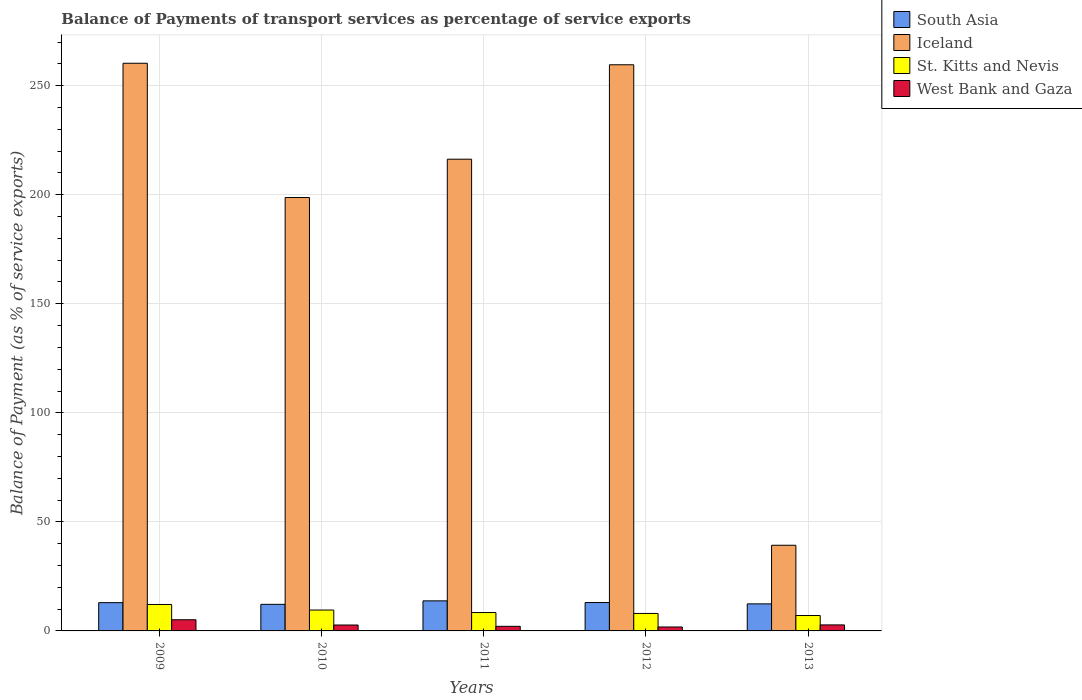How many different coloured bars are there?
Your answer should be very brief. 4. How many groups of bars are there?
Make the answer very short. 5. How many bars are there on the 4th tick from the right?
Give a very brief answer. 4. What is the label of the 3rd group of bars from the left?
Offer a terse response. 2011. What is the balance of payments of transport services in West Bank and Gaza in 2009?
Offer a very short reply. 5.12. Across all years, what is the maximum balance of payments of transport services in Iceland?
Keep it short and to the point. 260.27. Across all years, what is the minimum balance of payments of transport services in St. Kitts and Nevis?
Provide a short and direct response. 7.06. In which year was the balance of payments of transport services in Iceland maximum?
Give a very brief answer. 2009. In which year was the balance of payments of transport services in West Bank and Gaza minimum?
Keep it short and to the point. 2012. What is the total balance of payments of transport services in South Asia in the graph?
Offer a terse response. 64.36. What is the difference between the balance of payments of transport services in South Asia in 2009 and that in 2013?
Keep it short and to the point. 0.56. What is the difference between the balance of payments of transport services in South Asia in 2010 and the balance of payments of transport services in St. Kitts and Nevis in 2013?
Offer a very short reply. 5.13. What is the average balance of payments of transport services in West Bank and Gaza per year?
Give a very brief answer. 2.9. In the year 2013, what is the difference between the balance of payments of transport services in St. Kitts and Nevis and balance of payments of transport services in South Asia?
Provide a short and direct response. -5.34. What is the ratio of the balance of payments of transport services in Iceland in 2010 to that in 2013?
Offer a terse response. 5.06. Is the balance of payments of transport services in Iceland in 2012 less than that in 2013?
Provide a short and direct response. No. What is the difference between the highest and the second highest balance of payments of transport services in Iceland?
Provide a succinct answer. 0.7. What is the difference between the highest and the lowest balance of payments of transport services in Iceland?
Ensure brevity in your answer.  221. In how many years, is the balance of payments of transport services in South Asia greater than the average balance of payments of transport services in South Asia taken over all years?
Provide a succinct answer. 3. Is the sum of the balance of payments of transport services in South Asia in 2009 and 2011 greater than the maximum balance of payments of transport services in West Bank and Gaza across all years?
Provide a succinct answer. Yes. Is it the case that in every year, the sum of the balance of payments of transport services in South Asia and balance of payments of transport services in West Bank and Gaza is greater than the sum of balance of payments of transport services in St. Kitts and Nevis and balance of payments of transport services in Iceland?
Make the answer very short. No. What does the 4th bar from the left in 2009 represents?
Give a very brief answer. West Bank and Gaza. What does the 2nd bar from the right in 2010 represents?
Keep it short and to the point. St. Kitts and Nevis. Are the values on the major ticks of Y-axis written in scientific E-notation?
Offer a terse response. No. How many legend labels are there?
Provide a short and direct response. 4. What is the title of the graph?
Your response must be concise. Balance of Payments of transport services as percentage of service exports. Does "Korea (Republic)" appear as one of the legend labels in the graph?
Your response must be concise. No. What is the label or title of the Y-axis?
Ensure brevity in your answer.  Balance of Payment (as % of service exports). What is the Balance of Payment (as % of service exports) in South Asia in 2009?
Offer a terse response. 12.96. What is the Balance of Payment (as % of service exports) of Iceland in 2009?
Your response must be concise. 260.27. What is the Balance of Payment (as % of service exports) of St. Kitts and Nevis in 2009?
Provide a succinct answer. 12.13. What is the Balance of Payment (as % of service exports) in West Bank and Gaza in 2009?
Offer a terse response. 5.12. What is the Balance of Payment (as % of service exports) in South Asia in 2010?
Offer a terse response. 12.19. What is the Balance of Payment (as % of service exports) of Iceland in 2010?
Make the answer very short. 198.71. What is the Balance of Payment (as % of service exports) in St. Kitts and Nevis in 2010?
Offer a very short reply. 9.57. What is the Balance of Payment (as % of service exports) in West Bank and Gaza in 2010?
Offer a terse response. 2.71. What is the Balance of Payment (as % of service exports) of South Asia in 2011?
Make the answer very short. 13.79. What is the Balance of Payment (as % of service exports) in Iceland in 2011?
Make the answer very short. 216.28. What is the Balance of Payment (as % of service exports) of St. Kitts and Nevis in 2011?
Your response must be concise. 8.43. What is the Balance of Payment (as % of service exports) of West Bank and Gaza in 2011?
Provide a short and direct response. 2.1. What is the Balance of Payment (as % of service exports) of South Asia in 2012?
Offer a terse response. 13.02. What is the Balance of Payment (as % of service exports) of Iceland in 2012?
Give a very brief answer. 259.57. What is the Balance of Payment (as % of service exports) of St. Kitts and Nevis in 2012?
Your answer should be compact. 8.02. What is the Balance of Payment (as % of service exports) in West Bank and Gaza in 2012?
Your response must be concise. 1.81. What is the Balance of Payment (as % of service exports) in South Asia in 2013?
Give a very brief answer. 12.41. What is the Balance of Payment (as % of service exports) of Iceland in 2013?
Provide a succinct answer. 39.27. What is the Balance of Payment (as % of service exports) in St. Kitts and Nevis in 2013?
Your answer should be compact. 7.06. What is the Balance of Payment (as % of service exports) of West Bank and Gaza in 2013?
Your answer should be compact. 2.76. Across all years, what is the maximum Balance of Payment (as % of service exports) of South Asia?
Your answer should be compact. 13.79. Across all years, what is the maximum Balance of Payment (as % of service exports) in Iceland?
Your answer should be very brief. 260.27. Across all years, what is the maximum Balance of Payment (as % of service exports) of St. Kitts and Nevis?
Give a very brief answer. 12.13. Across all years, what is the maximum Balance of Payment (as % of service exports) in West Bank and Gaza?
Ensure brevity in your answer.  5.12. Across all years, what is the minimum Balance of Payment (as % of service exports) of South Asia?
Your response must be concise. 12.19. Across all years, what is the minimum Balance of Payment (as % of service exports) in Iceland?
Provide a short and direct response. 39.27. Across all years, what is the minimum Balance of Payment (as % of service exports) in St. Kitts and Nevis?
Your response must be concise. 7.06. Across all years, what is the minimum Balance of Payment (as % of service exports) in West Bank and Gaza?
Keep it short and to the point. 1.81. What is the total Balance of Payment (as % of service exports) in South Asia in the graph?
Ensure brevity in your answer.  64.36. What is the total Balance of Payment (as % of service exports) of Iceland in the graph?
Make the answer very short. 974.1. What is the total Balance of Payment (as % of service exports) of St. Kitts and Nevis in the graph?
Your response must be concise. 45.21. What is the total Balance of Payment (as % of service exports) of West Bank and Gaza in the graph?
Give a very brief answer. 14.5. What is the difference between the Balance of Payment (as % of service exports) of South Asia in 2009 and that in 2010?
Keep it short and to the point. 0.78. What is the difference between the Balance of Payment (as % of service exports) in Iceland in 2009 and that in 2010?
Ensure brevity in your answer.  61.56. What is the difference between the Balance of Payment (as % of service exports) of St. Kitts and Nevis in 2009 and that in 2010?
Offer a terse response. 2.56. What is the difference between the Balance of Payment (as % of service exports) in West Bank and Gaza in 2009 and that in 2010?
Your answer should be compact. 2.4. What is the difference between the Balance of Payment (as % of service exports) in South Asia in 2009 and that in 2011?
Your answer should be very brief. -0.82. What is the difference between the Balance of Payment (as % of service exports) of Iceland in 2009 and that in 2011?
Your answer should be compact. 43.99. What is the difference between the Balance of Payment (as % of service exports) in St. Kitts and Nevis in 2009 and that in 2011?
Make the answer very short. 3.7. What is the difference between the Balance of Payment (as % of service exports) of West Bank and Gaza in 2009 and that in 2011?
Provide a succinct answer. 3.01. What is the difference between the Balance of Payment (as % of service exports) of South Asia in 2009 and that in 2012?
Make the answer very short. -0.05. What is the difference between the Balance of Payment (as % of service exports) of Iceland in 2009 and that in 2012?
Offer a very short reply. 0.7. What is the difference between the Balance of Payment (as % of service exports) in St. Kitts and Nevis in 2009 and that in 2012?
Offer a terse response. 4.11. What is the difference between the Balance of Payment (as % of service exports) in West Bank and Gaza in 2009 and that in 2012?
Offer a very short reply. 3.31. What is the difference between the Balance of Payment (as % of service exports) in South Asia in 2009 and that in 2013?
Ensure brevity in your answer.  0.56. What is the difference between the Balance of Payment (as % of service exports) of Iceland in 2009 and that in 2013?
Give a very brief answer. 221. What is the difference between the Balance of Payment (as % of service exports) in St. Kitts and Nevis in 2009 and that in 2013?
Provide a short and direct response. 5.07. What is the difference between the Balance of Payment (as % of service exports) of West Bank and Gaza in 2009 and that in 2013?
Keep it short and to the point. 2.36. What is the difference between the Balance of Payment (as % of service exports) of South Asia in 2010 and that in 2011?
Keep it short and to the point. -1.6. What is the difference between the Balance of Payment (as % of service exports) of Iceland in 2010 and that in 2011?
Your answer should be compact. -17.57. What is the difference between the Balance of Payment (as % of service exports) of St. Kitts and Nevis in 2010 and that in 2011?
Provide a short and direct response. 1.14. What is the difference between the Balance of Payment (as % of service exports) of West Bank and Gaza in 2010 and that in 2011?
Ensure brevity in your answer.  0.61. What is the difference between the Balance of Payment (as % of service exports) in South Asia in 2010 and that in 2012?
Your answer should be very brief. -0.83. What is the difference between the Balance of Payment (as % of service exports) of Iceland in 2010 and that in 2012?
Provide a short and direct response. -60.86. What is the difference between the Balance of Payment (as % of service exports) in St. Kitts and Nevis in 2010 and that in 2012?
Your answer should be very brief. 1.56. What is the difference between the Balance of Payment (as % of service exports) in West Bank and Gaza in 2010 and that in 2012?
Offer a very short reply. 0.91. What is the difference between the Balance of Payment (as % of service exports) of South Asia in 2010 and that in 2013?
Your answer should be very brief. -0.22. What is the difference between the Balance of Payment (as % of service exports) of Iceland in 2010 and that in 2013?
Offer a terse response. 159.43. What is the difference between the Balance of Payment (as % of service exports) of St. Kitts and Nevis in 2010 and that in 2013?
Your answer should be very brief. 2.51. What is the difference between the Balance of Payment (as % of service exports) in West Bank and Gaza in 2010 and that in 2013?
Your answer should be very brief. -0.04. What is the difference between the Balance of Payment (as % of service exports) of South Asia in 2011 and that in 2012?
Your answer should be compact. 0.77. What is the difference between the Balance of Payment (as % of service exports) in Iceland in 2011 and that in 2012?
Give a very brief answer. -43.29. What is the difference between the Balance of Payment (as % of service exports) of St. Kitts and Nevis in 2011 and that in 2012?
Your response must be concise. 0.42. What is the difference between the Balance of Payment (as % of service exports) in West Bank and Gaza in 2011 and that in 2012?
Keep it short and to the point. 0.3. What is the difference between the Balance of Payment (as % of service exports) of South Asia in 2011 and that in 2013?
Provide a short and direct response. 1.38. What is the difference between the Balance of Payment (as % of service exports) in Iceland in 2011 and that in 2013?
Make the answer very short. 177.01. What is the difference between the Balance of Payment (as % of service exports) in St. Kitts and Nevis in 2011 and that in 2013?
Offer a terse response. 1.37. What is the difference between the Balance of Payment (as % of service exports) in West Bank and Gaza in 2011 and that in 2013?
Keep it short and to the point. -0.65. What is the difference between the Balance of Payment (as % of service exports) in South Asia in 2012 and that in 2013?
Ensure brevity in your answer.  0.61. What is the difference between the Balance of Payment (as % of service exports) in Iceland in 2012 and that in 2013?
Keep it short and to the point. 220.3. What is the difference between the Balance of Payment (as % of service exports) of St. Kitts and Nevis in 2012 and that in 2013?
Your answer should be compact. 0.95. What is the difference between the Balance of Payment (as % of service exports) of West Bank and Gaza in 2012 and that in 2013?
Give a very brief answer. -0.95. What is the difference between the Balance of Payment (as % of service exports) in South Asia in 2009 and the Balance of Payment (as % of service exports) in Iceland in 2010?
Your answer should be very brief. -185.74. What is the difference between the Balance of Payment (as % of service exports) in South Asia in 2009 and the Balance of Payment (as % of service exports) in St. Kitts and Nevis in 2010?
Offer a terse response. 3.39. What is the difference between the Balance of Payment (as % of service exports) of South Asia in 2009 and the Balance of Payment (as % of service exports) of West Bank and Gaza in 2010?
Offer a terse response. 10.25. What is the difference between the Balance of Payment (as % of service exports) in Iceland in 2009 and the Balance of Payment (as % of service exports) in St. Kitts and Nevis in 2010?
Give a very brief answer. 250.7. What is the difference between the Balance of Payment (as % of service exports) of Iceland in 2009 and the Balance of Payment (as % of service exports) of West Bank and Gaza in 2010?
Offer a terse response. 257.55. What is the difference between the Balance of Payment (as % of service exports) in St. Kitts and Nevis in 2009 and the Balance of Payment (as % of service exports) in West Bank and Gaza in 2010?
Keep it short and to the point. 9.41. What is the difference between the Balance of Payment (as % of service exports) in South Asia in 2009 and the Balance of Payment (as % of service exports) in Iceland in 2011?
Provide a short and direct response. -203.32. What is the difference between the Balance of Payment (as % of service exports) in South Asia in 2009 and the Balance of Payment (as % of service exports) in St. Kitts and Nevis in 2011?
Offer a terse response. 4.53. What is the difference between the Balance of Payment (as % of service exports) of South Asia in 2009 and the Balance of Payment (as % of service exports) of West Bank and Gaza in 2011?
Provide a succinct answer. 10.86. What is the difference between the Balance of Payment (as % of service exports) of Iceland in 2009 and the Balance of Payment (as % of service exports) of St. Kitts and Nevis in 2011?
Offer a very short reply. 251.84. What is the difference between the Balance of Payment (as % of service exports) in Iceland in 2009 and the Balance of Payment (as % of service exports) in West Bank and Gaza in 2011?
Provide a succinct answer. 258.16. What is the difference between the Balance of Payment (as % of service exports) in St. Kitts and Nevis in 2009 and the Balance of Payment (as % of service exports) in West Bank and Gaza in 2011?
Keep it short and to the point. 10.02. What is the difference between the Balance of Payment (as % of service exports) in South Asia in 2009 and the Balance of Payment (as % of service exports) in Iceland in 2012?
Your answer should be very brief. -246.61. What is the difference between the Balance of Payment (as % of service exports) of South Asia in 2009 and the Balance of Payment (as % of service exports) of St. Kitts and Nevis in 2012?
Provide a succinct answer. 4.95. What is the difference between the Balance of Payment (as % of service exports) in South Asia in 2009 and the Balance of Payment (as % of service exports) in West Bank and Gaza in 2012?
Provide a short and direct response. 11.16. What is the difference between the Balance of Payment (as % of service exports) of Iceland in 2009 and the Balance of Payment (as % of service exports) of St. Kitts and Nevis in 2012?
Give a very brief answer. 252.25. What is the difference between the Balance of Payment (as % of service exports) in Iceland in 2009 and the Balance of Payment (as % of service exports) in West Bank and Gaza in 2012?
Provide a succinct answer. 258.46. What is the difference between the Balance of Payment (as % of service exports) of St. Kitts and Nevis in 2009 and the Balance of Payment (as % of service exports) of West Bank and Gaza in 2012?
Keep it short and to the point. 10.32. What is the difference between the Balance of Payment (as % of service exports) in South Asia in 2009 and the Balance of Payment (as % of service exports) in Iceland in 2013?
Provide a short and direct response. -26.31. What is the difference between the Balance of Payment (as % of service exports) in South Asia in 2009 and the Balance of Payment (as % of service exports) in St. Kitts and Nevis in 2013?
Ensure brevity in your answer.  5.9. What is the difference between the Balance of Payment (as % of service exports) in South Asia in 2009 and the Balance of Payment (as % of service exports) in West Bank and Gaza in 2013?
Keep it short and to the point. 10.21. What is the difference between the Balance of Payment (as % of service exports) in Iceland in 2009 and the Balance of Payment (as % of service exports) in St. Kitts and Nevis in 2013?
Offer a terse response. 253.21. What is the difference between the Balance of Payment (as % of service exports) of Iceland in 2009 and the Balance of Payment (as % of service exports) of West Bank and Gaza in 2013?
Offer a terse response. 257.51. What is the difference between the Balance of Payment (as % of service exports) in St. Kitts and Nevis in 2009 and the Balance of Payment (as % of service exports) in West Bank and Gaza in 2013?
Give a very brief answer. 9.37. What is the difference between the Balance of Payment (as % of service exports) of South Asia in 2010 and the Balance of Payment (as % of service exports) of Iceland in 2011?
Your answer should be very brief. -204.09. What is the difference between the Balance of Payment (as % of service exports) in South Asia in 2010 and the Balance of Payment (as % of service exports) in St. Kitts and Nevis in 2011?
Ensure brevity in your answer.  3.75. What is the difference between the Balance of Payment (as % of service exports) in South Asia in 2010 and the Balance of Payment (as % of service exports) in West Bank and Gaza in 2011?
Your response must be concise. 10.08. What is the difference between the Balance of Payment (as % of service exports) in Iceland in 2010 and the Balance of Payment (as % of service exports) in St. Kitts and Nevis in 2011?
Your response must be concise. 190.28. What is the difference between the Balance of Payment (as % of service exports) of Iceland in 2010 and the Balance of Payment (as % of service exports) of West Bank and Gaza in 2011?
Offer a terse response. 196.6. What is the difference between the Balance of Payment (as % of service exports) in St. Kitts and Nevis in 2010 and the Balance of Payment (as % of service exports) in West Bank and Gaza in 2011?
Offer a very short reply. 7.47. What is the difference between the Balance of Payment (as % of service exports) in South Asia in 2010 and the Balance of Payment (as % of service exports) in Iceland in 2012?
Make the answer very short. -247.38. What is the difference between the Balance of Payment (as % of service exports) in South Asia in 2010 and the Balance of Payment (as % of service exports) in St. Kitts and Nevis in 2012?
Provide a short and direct response. 4.17. What is the difference between the Balance of Payment (as % of service exports) of South Asia in 2010 and the Balance of Payment (as % of service exports) of West Bank and Gaza in 2012?
Keep it short and to the point. 10.38. What is the difference between the Balance of Payment (as % of service exports) in Iceland in 2010 and the Balance of Payment (as % of service exports) in St. Kitts and Nevis in 2012?
Give a very brief answer. 190.69. What is the difference between the Balance of Payment (as % of service exports) in Iceland in 2010 and the Balance of Payment (as % of service exports) in West Bank and Gaza in 2012?
Your answer should be very brief. 196.9. What is the difference between the Balance of Payment (as % of service exports) in St. Kitts and Nevis in 2010 and the Balance of Payment (as % of service exports) in West Bank and Gaza in 2012?
Provide a succinct answer. 7.77. What is the difference between the Balance of Payment (as % of service exports) of South Asia in 2010 and the Balance of Payment (as % of service exports) of Iceland in 2013?
Provide a succinct answer. -27.09. What is the difference between the Balance of Payment (as % of service exports) in South Asia in 2010 and the Balance of Payment (as % of service exports) in St. Kitts and Nevis in 2013?
Keep it short and to the point. 5.13. What is the difference between the Balance of Payment (as % of service exports) in South Asia in 2010 and the Balance of Payment (as % of service exports) in West Bank and Gaza in 2013?
Offer a very short reply. 9.43. What is the difference between the Balance of Payment (as % of service exports) in Iceland in 2010 and the Balance of Payment (as % of service exports) in St. Kitts and Nevis in 2013?
Provide a succinct answer. 191.65. What is the difference between the Balance of Payment (as % of service exports) of Iceland in 2010 and the Balance of Payment (as % of service exports) of West Bank and Gaza in 2013?
Give a very brief answer. 195.95. What is the difference between the Balance of Payment (as % of service exports) in St. Kitts and Nevis in 2010 and the Balance of Payment (as % of service exports) in West Bank and Gaza in 2013?
Give a very brief answer. 6.81. What is the difference between the Balance of Payment (as % of service exports) in South Asia in 2011 and the Balance of Payment (as % of service exports) in Iceland in 2012?
Provide a succinct answer. -245.78. What is the difference between the Balance of Payment (as % of service exports) in South Asia in 2011 and the Balance of Payment (as % of service exports) in St. Kitts and Nevis in 2012?
Your answer should be very brief. 5.77. What is the difference between the Balance of Payment (as % of service exports) of South Asia in 2011 and the Balance of Payment (as % of service exports) of West Bank and Gaza in 2012?
Your answer should be very brief. 11.98. What is the difference between the Balance of Payment (as % of service exports) in Iceland in 2011 and the Balance of Payment (as % of service exports) in St. Kitts and Nevis in 2012?
Your answer should be compact. 208.27. What is the difference between the Balance of Payment (as % of service exports) in Iceland in 2011 and the Balance of Payment (as % of service exports) in West Bank and Gaza in 2012?
Offer a very short reply. 214.48. What is the difference between the Balance of Payment (as % of service exports) of St. Kitts and Nevis in 2011 and the Balance of Payment (as % of service exports) of West Bank and Gaza in 2012?
Give a very brief answer. 6.63. What is the difference between the Balance of Payment (as % of service exports) in South Asia in 2011 and the Balance of Payment (as % of service exports) in Iceland in 2013?
Ensure brevity in your answer.  -25.49. What is the difference between the Balance of Payment (as % of service exports) in South Asia in 2011 and the Balance of Payment (as % of service exports) in St. Kitts and Nevis in 2013?
Offer a very short reply. 6.73. What is the difference between the Balance of Payment (as % of service exports) of South Asia in 2011 and the Balance of Payment (as % of service exports) of West Bank and Gaza in 2013?
Ensure brevity in your answer.  11.03. What is the difference between the Balance of Payment (as % of service exports) of Iceland in 2011 and the Balance of Payment (as % of service exports) of St. Kitts and Nevis in 2013?
Make the answer very short. 209.22. What is the difference between the Balance of Payment (as % of service exports) of Iceland in 2011 and the Balance of Payment (as % of service exports) of West Bank and Gaza in 2013?
Provide a short and direct response. 213.52. What is the difference between the Balance of Payment (as % of service exports) of St. Kitts and Nevis in 2011 and the Balance of Payment (as % of service exports) of West Bank and Gaza in 2013?
Offer a terse response. 5.67. What is the difference between the Balance of Payment (as % of service exports) of South Asia in 2012 and the Balance of Payment (as % of service exports) of Iceland in 2013?
Give a very brief answer. -26.25. What is the difference between the Balance of Payment (as % of service exports) of South Asia in 2012 and the Balance of Payment (as % of service exports) of St. Kitts and Nevis in 2013?
Provide a succinct answer. 5.96. What is the difference between the Balance of Payment (as % of service exports) in South Asia in 2012 and the Balance of Payment (as % of service exports) in West Bank and Gaza in 2013?
Keep it short and to the point. 10.26. What is the difference between the Balance of Payment (as % of service exports) of Iceland in 2012 and the Balance of Payment (as % of service exports) of St. Kitts and Nevis in 2013?
Provide a short and direct response. 252.51. What is the difference between the Balance of Payment (as % of service exports) in Iceland in 2012 and the Balance of Payment (as % of service exports) in West Bank and Gaza in 2013?
Offer a terse response. 256.81. What is the difference between the Balance of Payment (as % of service exports) of St. Kitts and Nevis in 2012 and the Balance of Payment (as % of service exports) of West Bank and Gaza in 2013?
Ensure brevity in your answer.  5.26. What is the average Balance of Payment (as % of service exports) in South Asia per year?
Your answer should be very brief. 12.87. What is the average Balance of Payment (as % of service exports) in Iceland per year?
Keep it short and to the point. 194.82. What is the average Balance of Payment (as % of service exports) of St. Kitts and Nevis per year?
Make the answer very short. 9.04. What is the average Balance of Payment (as % of service exports) in West Bank and Gaza per year?
Keep it short and to the point. 2.9. In the year 2009, what is the difference between the Balance of Payment (as % of service exports) in South Asia and Balance of Payment (as % of service exports) in Iceland?
Offer a terse response. -247.3. In the year 2009, what is the difference between the Balance of Payment (as % of service exports) in South Asia and Balance of Payment (as % of service exports) in St. Kitts and Nevis?
Your response must be concise. 0.84. In the year 2009, what is the difference between the Balance of Payment (as % of service exports) of South Asia and Balance of Payment (as % of service exports) of West Bank and Gaza?
Provide a short and direct response. 7.85. In the year 2009, what is the difference between the Balance of Payment (as % of service exports) in Iceland and Balance of Payment (as % of service exports) in St. Kitts and Nevis?
Your response must be concise. 248.14. In the year 2009, what is the difference between the Balance of Payment (as % of service exports) of Iceland and Balance of Payment (as % of service exports) of West Bank and Gaza?
Keep it short and to the point. 255.15. In the year 2009, what is the difference between the Balance of Payment (as % of service exports) in St. Kitts and Nevis and Balance of Payment (as % of service exports) in West Bank and Gaza?
Ensure brevity in your answer.  7.01. In the year 2010, what is the difference between the Balance of Payment (as % of service exports) of South Asia and Balance of Payment (as % of service exports) of Iceland?
Your answer should be compact. -186.52. In the year 2010, what is the difference between the Balance of Payment (as % of service exports) in South Asia and Balance of Payment (as % of service exports) in St. Kitts and Nevis?
Offer a very short reply. 2.61. In the year 2010, what is the difference between the Balance of Payment (as % of service exports) of South Asia and Balance of Payment (as % of service exports) of West Bank and Gaza?
Give a very brief answer. 9.47. In the year 2010, what is the difference between the Balance of Payment (as % of service exports) in Iceland and Balance of Payment (as % of service exports) in St. Kitts and Nevis?
Ensure brevity in your answer.  189.14. In the year 2010, what is the difference between the Balance of Payment (as % of service exports) of Iceland and Balance of Payment (as % of service exports) of West Bank and Gaza?
Keep it short and to the point. 195.99. In the year 2010, what is the difference between the Balance of Payment (as % of service exports) in St. Kitts and Nevis and Balance of Payment (as % of service exports) in West Bank and Gaza?
Make the answer very short. 6.86. In the year 2011, what is the difference between the Balance of Payment (as % of service exports) of South Asia and Balance of Payment (as % of service exports) of Iceland?
Your response must be concise. -202.49. In the year 2011, what is the difference between the Balance of Payment (as % of service exports) of South Asia and Balance of Payment (as % of service exports) of St. Kitts and Nevis?
Your answer should be compact. 5.35. In the year 2011, what is the difference between the Balance of Payment (as % of service exports) in South Asia and Balance of Payment (as % of service exports) in West Bank and Gaza?
Keep it short and to the point. 11.68. In the year 2011, what is the difference between the Balance of Payment (as % of service exports) in Iceland and Balance of Payment (as % of service exports) in St. Kitts and Nevis?
Keep it short and to the point. 207.85. In the year 2011, what is the difference between the Balance of Payment (as % of service exports) in Iceland and Balance of Payment (as % of service exports) in West Bank and Gaza?
Make the answer very short. 214.18. In the year 2011, what is the difference between the Balance of Payment (as % of service exports) of St. Kitts and Nevis and Balance of Payment (as % of service exports) of West Bank and Gaza?
Offer a terse response. 6.33. In the year 2012, what is the difference between the Balance of Payment (as % of service exports) of South Asia and Balance of Payment (as % of service exports) of Iceland?
Provide a short and direct response. -246.55. In the year 2012, what is the difference between the Balance of Payment (as % of service exports) in South Asia and Balance of Payment (as % of service exports) in St. Kitts and Nevis?
Ensure brevity in your answer.  5. In the year 2012, what is the difference between the Balance of Payment (as % of service exports) in South Asia and Balance of Payment (as % of service exports) in West Bank and Gaza?
Your answer should be compact. 11.21. In the year 2012, what is the difference between the Balance of Payment (as % of service exports) in Iceland and Balance of Payment (as % of service exports) in St. Kitts and Nevis?
Provide a short and direct response. 251.56. In the year 2012, what is the difference between the Balance of Payment (as % of service exports) in Iceland and Balance of Payment (as % of service exports) in West Bank and Gaza?
Your answer should be very brief. 257.77. In the year 2012, what is the difference between the Balance of Payment (as % of service exports) in St. Kitts and Nevis and Balance of Payment (as % of service exports) in West Bank and Gaza?
Give a very brief answer. 6.21. In the year 2013, what is the difference between the Balance of Payment (as % of service exports) of South Asia and Balance of Payment (as % of service exports) of Iceland?
Provide a short and direct response. -26.87. In the year 2013, what is the difference between the Balance of Payment (as % of service exports) in South Asia and Balance of Payment (as % of service exports) in St. Kitts and Nevis?
Provide a succinct answer. 5.34. In the year 2013, what is the difference between the Balance of Payment (as % of service exports) of South Asia and Balance of Payment (as % of service exports) of West Bank and Gaza?
Your response must be concise. 9.65. In the year 2013, what is the difference between the Balance of Payment (as % of service exports) in Iceland and Balance of Payment (as % of service exports) in St. Kitts and Nevis?
Keep it short and to the point. 32.21. In the year 2013, what is the difference between the Balance of Payment (as % of service exports) of Iceland and Balance of Payment (as % of service exports) of West Bank and Gaza?
Offer a very short reply. 36.52. In the year 2013, what is the difference between the Balance of Payment (as % of service exports) in St. Kitts and Nevis and Balance of Payment (as % of service exports) in West Bank and Gaza?
Offer a terse response. 4.3. What is the ratio of the Balance of Payment (as % of service exports) in South Asia in 2009 to that in 2010?
Your response must be concise. 1.06. What is the ratio of the Balance of Payment (as % of service exports) in Iceland in 2009 to that in 2010?
Your answer should be very brief. 1.31. What is the ratio of the Balance of Payment (as % of service exports) of St. Kitts and Nevis in 2009 to that in 2010?
Ensure brevity in your answer.  1.27. What is the ratio of the Balance of Payment (as % of service exports) of West Bank and Gaza in 2009 to that in 2010?
Provide a short and direct response. 1.89. What is the ratio of the Balance of Payment (as % of service exports) in South Asia in 2009 to that in 2011?
Your answer should be very brief. 0.94. What is the ratio of the Balance of Payment (as % of service exports) in Iceland in 2009 to that in 2011?
Offer a very short reply. 1.2. What is the ratio of the Balance of Payment (as % of service exports) in St. Kitts and Nevis in 2009 to that in 2011?
Keep it short and to the point. 1.44. What is the ratio of the Balance of Payment (as % of service exports) of West Bank and Gaza in 2009 to that in 2011?
Provide a succinct answer. 2.43. What is the ratio of the Balance of Payment (as % of service exports) in St. Kitts and Nevis in 2009 to that in 2012?
Offer a very short reply. 1.51. What is the ratio of the Balance of Payment (as % of service exports) in West Bank and Gaza in 2009 to that in 2012?
Your response must be concise. 2.83. What is the ratio of the Balance of Payment (as % of service exports) of South Asia in 2009 to that in 2013?
Offer a terse response. 1.05. What is the ratio of the Balance of Payment (as % of service exports) of Iceland in 2009 to that in 2013?
Offer a very short reply. 6.63. What is the ratio of the Balance of Payment (as % of service exports) in St. Kitts and Nevis in 2009 to that in 2013?
Ensure brevity in your answer.  1.72. What is the ratio of the Balance of Payment (as % of service exports) of West Bank and Gaza in 2009 to that in 2013?
Your answer should be compact. 1.85. What is the ratio of the Balance of Payment (as % of service exports) in South Asia in 2010 to that in 2011?
Offer a very short reply. 0.88. What is the ratio of the Balance of Payment (as % of service exports) in Iceland in 2010 to that in 2011?
Provide a short and direct response. 0.92. What is the ratio of the Balance of Payment (as % of service exports) of St. Kitts and Nevis in 2010 to that in 2011?
Your response must be concise. 1.14. What is the ratio of the Balance of Payment (as % of service exports) of West Bank and Gaza in 2010 to that in 2011?
Offer a very short reply. 1.29. What is the ratio of the Balance of Payment (as % of service exports) of South Asia in 2010 to that in 2012?
Your answer should be compact. 0.94. What is the ratio of the Balance of Payment (as % of service exports) of Iceland in 2010 to that in 2012?
Your answer should be compact. 0.77. What is the ratio of the Balance of Payment (as % of service exports) in St. Kitts and Nevis in 2010 to that in 2012?
Make the answer very short. 1.19. What is the ratio of the Balance of Payment (as % of service exports) in West Bank and Gaza in 2010 to that in 2012?
Provide a succinct answer. 1.5. What is the ratio of the Balance of Payment (as % of service exports) of South Asia in 2010 to that in 2013?
Your response must be concise. 0.98. What is the ratio of the Balance of Payment (as % of service exports) in Iceland in 2010 to that in 2013?
Keep it short and to the point. 5.06. What is the ratio of the Balance of Payment (as % of service exports) in St. Kitts and Nevis in 2010 to that in 2013?
Provide a short and direct response. 1.36. What is the ratio of the Balance of Payment (as % of service exports) of West Bank and Gaza in 2010 to that in 2013?
Ensure brevity in your answer.  0.98. What is the ratio of the Balance of Payment (as % of service exports) of South Asia in 2011 to that in 2012?
Give a very brief answer. 1.06. What is the ratio of the Balance of Payment (as % of service exports) in Iceland in 2011 to that in 2012?
Offer a terse response. 0.83. What is the ratio of the Balance of Payment (as % of service exports) in St. Kitts and Nevis in 2011 to that in 2012?
Give a very brief answer. 1.05. What is the ratio of the Balance of Payment (as % of service exports) of West Bank and Gaza in 2011 to that in 2012?
Provide a succinct answer. 1.17. What is the ratio of the Balance of Payment (as % of service exports) in South Asia in 2011 to that in 2013?
Ensure brevity in your answer.  1.11. What is the ratio of the Balance of Payment (as % of service exports) in Iceland in 2011 to that in 2013?
Your response must be concise. 5.51. What is the ratio of the Balance of Payment (as % of service exports) in St. Kitts and Nevis in 2011 to that in 2013?
Provide a succinct answer. 1.19. What is the ratio of the Balance of Payment (as % of service exports) in West Bank and Gaza in 2011 to that in 2013?
Your answer should be very brief. 0.76. What is the ratio of the Balance of Payment (as % of service exports) of South Asia in 2012 to that in 2013?
Give a very brief answer. 1.05. What is the ratio of the Balance of Payment (as % of service exports) of Iceland in 2012 to that in 2013?
Your answer should be compact. 6.61. What is the ratio of the Balance of Payment (as % of service exports) of St. Kitts and Nevis in 2012 to that in 2013?
Your response must be concise. 1.14. What is the ratio of the Balance of Payment (as % of service exports) in West Bank and Gaza in 2012 to that in 2013?
Provide a short and direct response. 0.65. What is the difference between the highest and the second highest Balance of Payment (as % of service exports) of South Asia?
Ensure brevity in your answer.  0.77. What is the difference between the highest and the second highest Balance of Payment (as % of service exports) of Iceland?
Provide a succinct answer. 0.7. What is the difference between the highest and the second highest Balance of Payment (as % of service exports) in St. Kitts and Nevis?
Your response must be concise. 2.56. What is the difference between the highest and the second highest Balance of Payment (as % of service exports) in West Bank and Gaza?
Give a very brief answer. 2.36. What is the difference between the highest and the lowest Balance of Payment (as % of service exports) in South Asia?
Your answer should be compact. 1.6. What is the difference between the highest and the lowest Balance of Payment (as % of service exports) of Iceland?
Give a very brief answer. 221. What is the difference between the highest and the lowest Balance of Payment (as % of service exports) of St. Kitts and Nevis?
Your response must be concise. 5.07. What is the difference between the highest and the lowest Balance of Payment (as % of service exports) of West Bank and Gaza?
Ensure brevity in your answer.  3.31. 